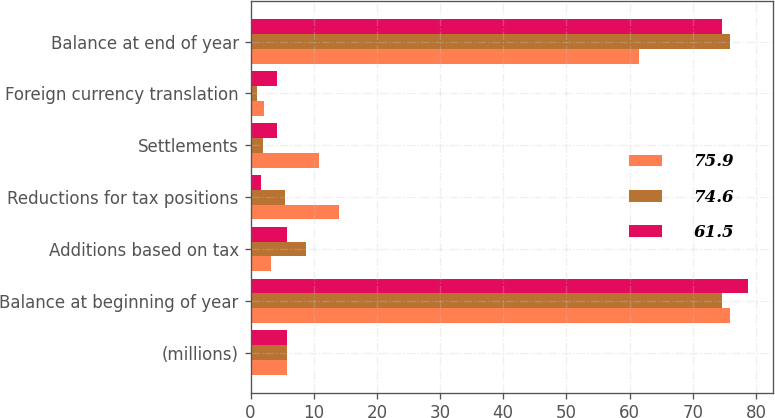<chart> <loc_0><loc_0><loc_500><loc_500><stacked_bar_chart><ecel><fcel>(millions)<fcel>Balance at beginning of year<fcel>Additions based on tax<fcel>Reductions for tax positions<fcel>Settlements<fcel>Foreign currency translation<fcel>Balance at end of year<nl><fcel>75.9<fcel>5.8<fcel>75.9<fcel>3.2<fcel>14<fcel>10.8<fcel>2.1<fcel>61.5<nl><fcel>74.6<fcel>5.8<fcel>74.6<fcel>8.8<fcel>5.5<fcel>2<fcel>1.1<fcel>75.9<nl><fcel>61.5<fcel>5.8<fcel>78.7<fcel>5.8<fcel>1.6<fcel>4.2<fcel>4.2<fcel>74.6<nl></chart> 